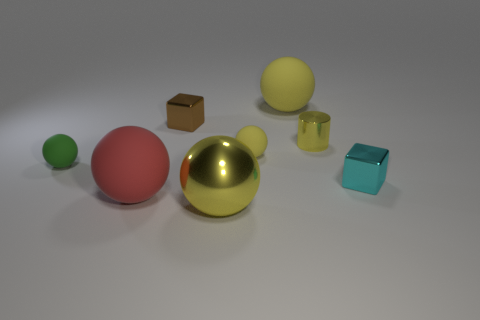Is there any other thing that is the same size as the brown metallic object?
Keep it short and to the point. Yes. Is there any other thing that has the same shape as the small yellow metallic thing?
Ensure brevity in your answer.  No. The small cube that is behind the small matte thing that is right of the tiny matte sphere to the left of the large red sphere is made of what material?
Give a very brief answer. Metal. Do the tiny green rubber object and the red rubber object have the same shape?
Your answer should be very brief. Yes. How many rubber things are either large green cylinders or brown objects?
Provide a short and direct response. 0. What number of brown shiny things are there?
Give a very brief answer. 1. What is the color of the cylinder that is the same size as the cyan shiny object?
Your answer should be very brief. Yellow. Is the size of the green rubber sphere the same as the red matte sphere?
Keep it short and to the point. No. There is another metallic thing that is the same color as the big shiny object; what is its shape?
Your answer should be very brief. Cylinder. There is a green object; is its size the same as the sphere that is behind the brown thing?
Make the answer very short. No. 